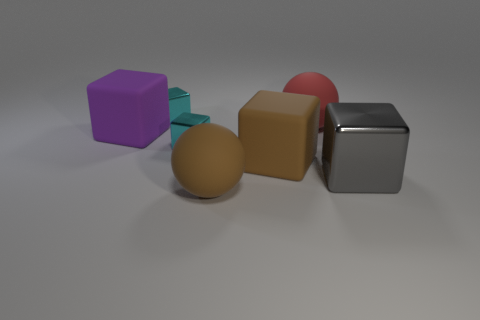There is a ball that is behind the matte block that is on the left side of the cyan shiny cube behind the red rubber sphere; what is its material?
Offer a terse response. Rubber. What material is the purple block that is left of the red rubber sphere?
Offer a terse response. Rubber. Are there any brown rubber balls that have the same size as the brown block?
Ensure brevity in your answer.  Yes. There is a large object in front of the large metallic block; does it have the same color as the large shiny thing?
Your answer should be compact. No. What number of red things are cubes or big objects?
Offer a terse response. 1. Does the big red object have the same material as the large purple cube?
Offer a very short reply. Yes. There is a big rubber ball in front of the big gray metallic object; what number of purple blocks are behind it?
Provide a succinct answer. 1. Is the size of the red object the same as the brown sphere?
Ensure brevity in your answer.  Yes. How many purple things have the same material as the gray thing?
Your answer should be compact. 0. Is the shape of the large metallic thing that is on the right side of the brown cube the same as  the red thing?
Keep it short and to the point. No. 